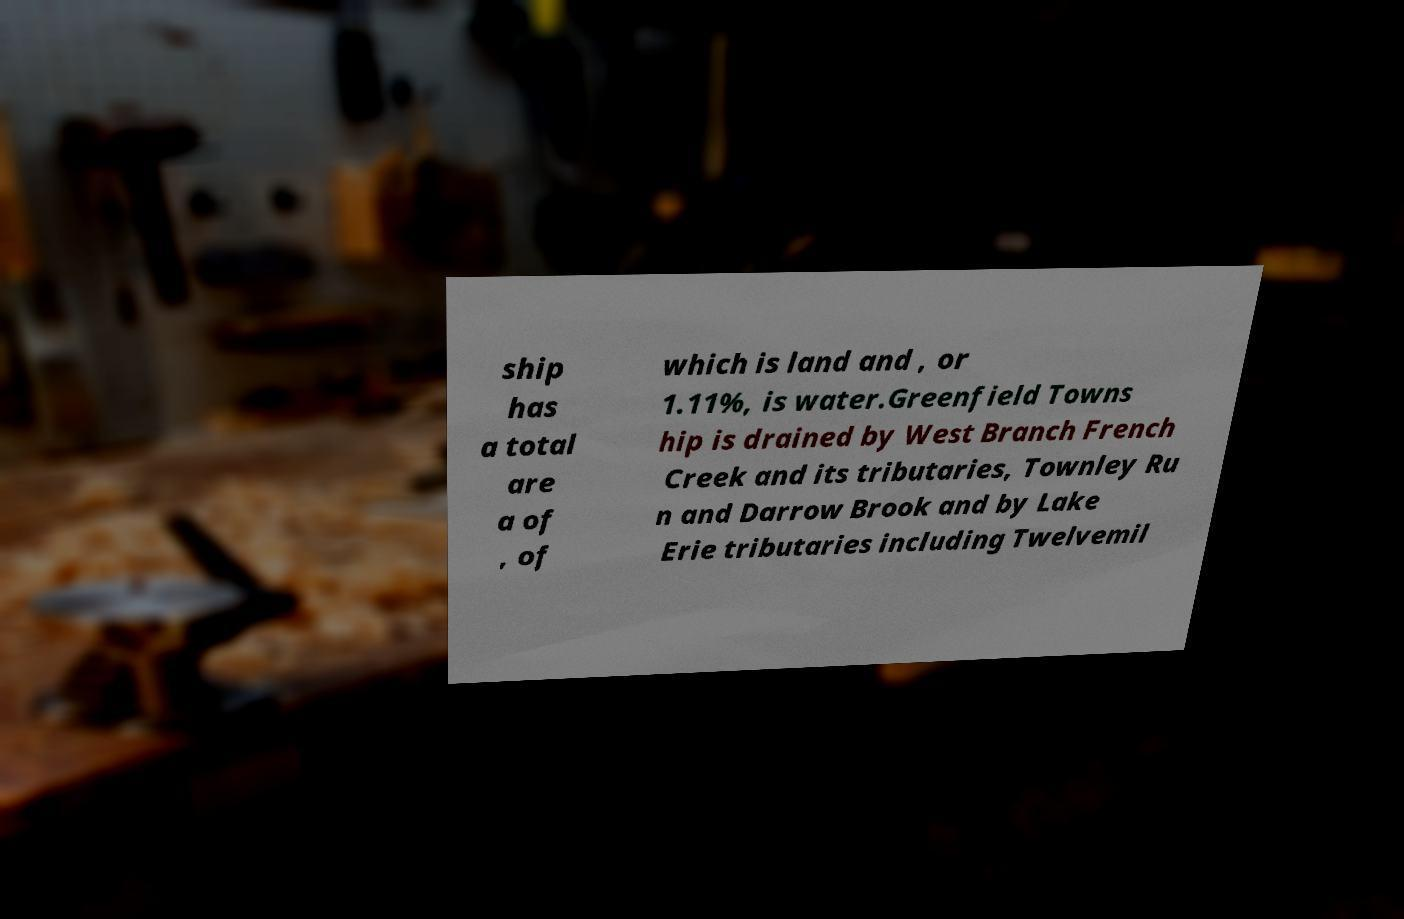What messages or text are displayed in this image? I need them in a readable, typed format. ship has a total are a of , of which is land and , or 1.11%, is water.Greenfield Towns hip is drained by West Branch French Creek and its tributaries, Townley Ru n and Darrow Brook and by Lake Erie tributaries including Twelvemil 